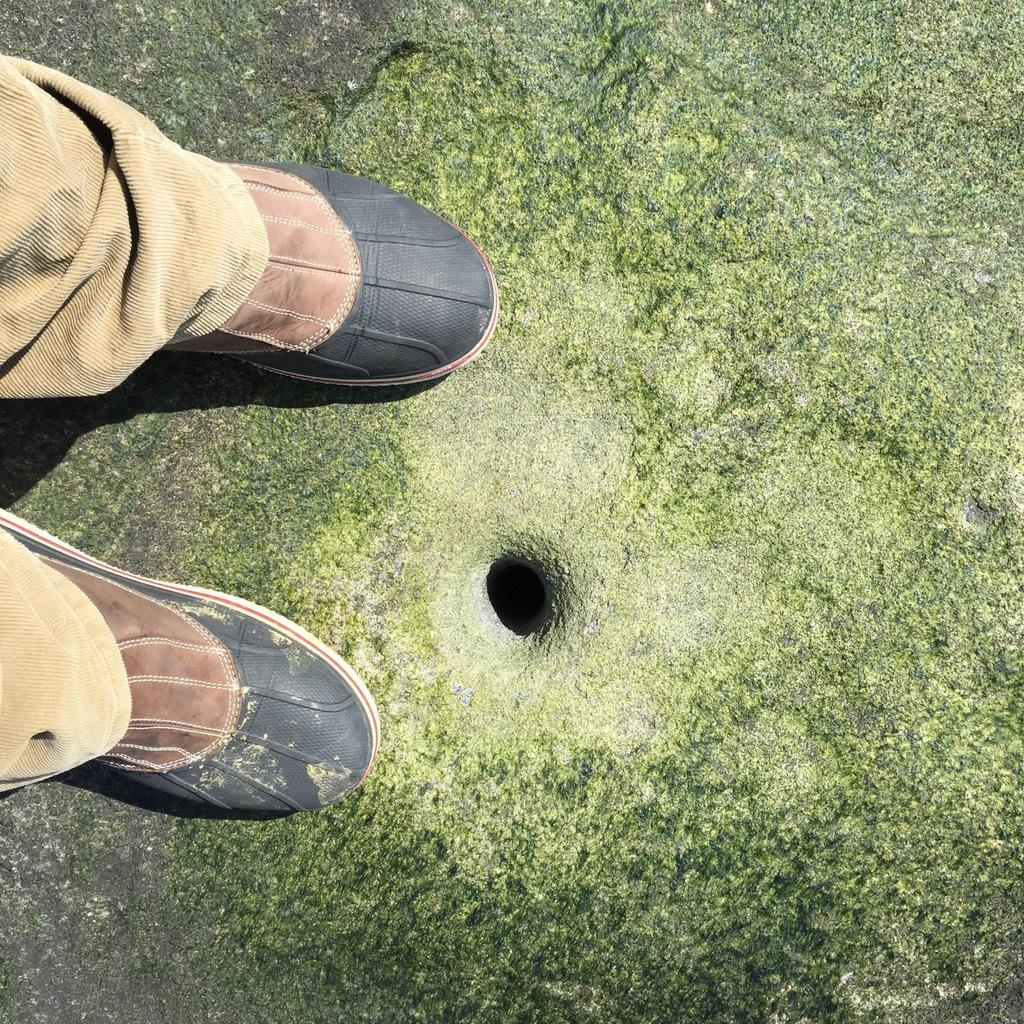What part of a person can be seen in the image? There are legs of a person in the image. What feature is present on the ground in the image? There is a hole on the ground in the image. Can you see a tiger swimming in the lake in the image? There is no lake or tiger present in the image. 